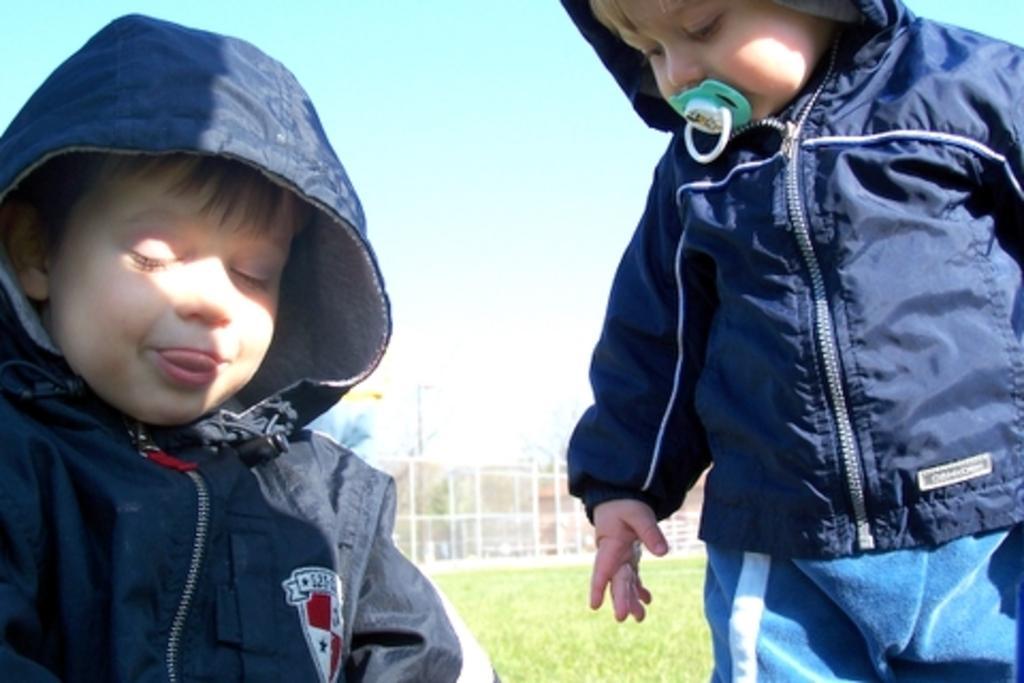Could you give a brief overview of what you see in this image? In this image I can see two persons. The person at right standing wearing blue jacket. Background I can see grass in green color, few poles and the sky is in blue and white color. 